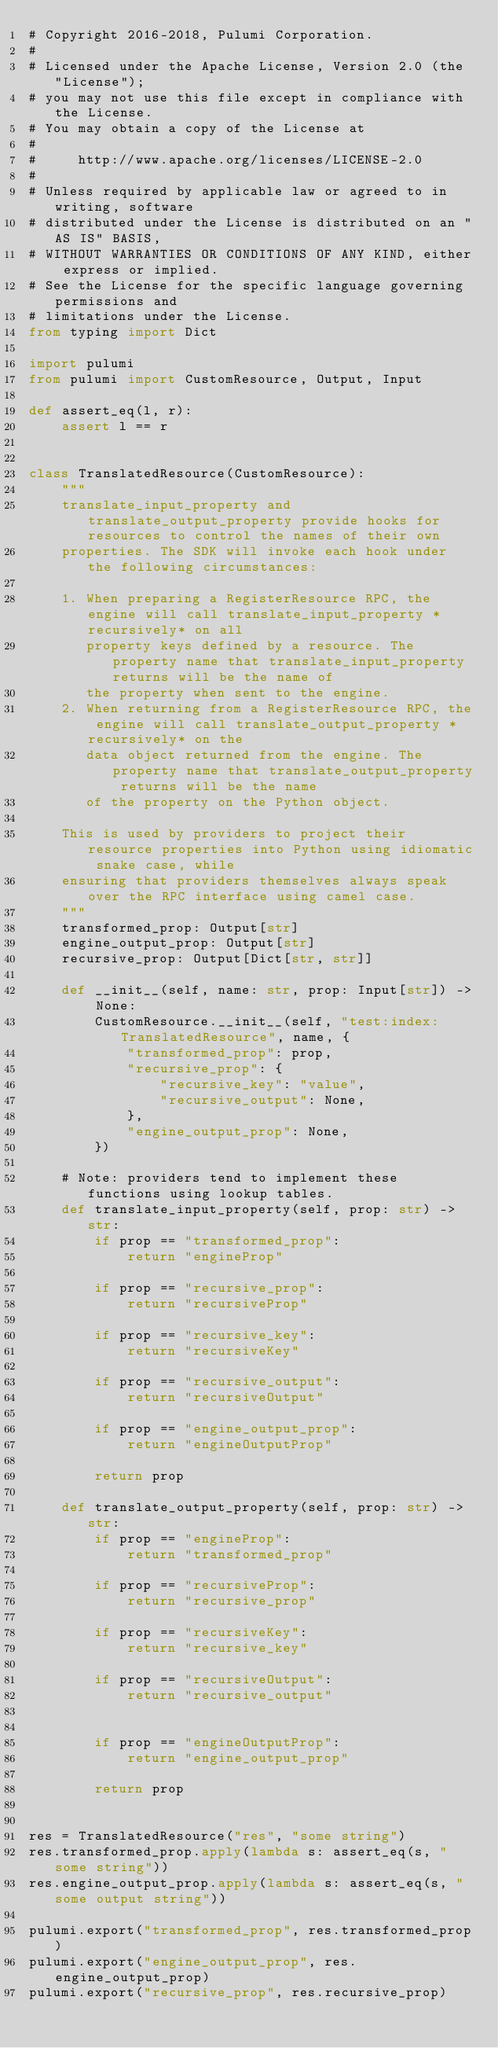Convert code to text. <code><loc_0><loc_0><loc_500><loc_500><_Python_># Copyright 2016-2018, Pulumi Corporation.
#
# Licensed under the Apache License, Version 2.0 (the "License");
# you may not use this file except in compliance with the License.
# You may obtain a copy of the License at
#
#     http://www.apache.org/licenses/LICENSE-2.0
#
# Unless required by applicable law or agreed to in writing, software
# distributed under the License is distributed on an "AS IS" BASIS,
# WITHOUT WARRANTIES OR CONDITIONS OF ANY KIND, either express or implied.
# See the License for the specific language governing permissions and
# limitations under the License.
from typing import Dict

import pulumi
from pulumi import CustomResource, Output, Input

def assert_eq(l, r):
    assert l == r


class TranslatedResource(CustomResource):
    """
    translate_input_property and translate_output_property provide hooks for resources to control the names of their own
    properties. The SDK will invoke each hook under the following circumstances:

    1. When preparing a RegisterResource RPC, the engine will call translate_input_property *recursively* on all
       property keys defined by a resource. The property name that translate_input_property returns will be the name of
       the property when sent to the engine.
    2. When returning from a RegisterResource RPC, the engine will call translate_output_property *recursively* on the
       data object returned from the engine. The property name that translate_output_property returns will be the name
       of the property on the Python object.

    This is used by providers to project their resource properties into Python using idiomatic snake case, while
    ensuring that providers themselves always speak over the RPC interface using camel case.
    """
    transformed_prop: Output[str]
    engine_output_prop: Output[str]
    recursive_prop: Output[Dict[str, str]]

    def __init__(self, name: str, prop: Input[str]) -> None:
        CustomResource.__init__(self, "test:index:TranslatedResource", name, {
            "transformed_prop": prop,
            "recursive_prop": {
                "recursive_key": "value",
                "recursive_output": None,
            },
            "engine_output_prop": None,
        })

    # Note: providers tend to implement these functions using lookup tables.
    def translate_input_property(self, prop: str) -> str:
        if prop == "transformed_prop":
            return "engineProp"

        if prop == "recursive_prop":
            return "recursiveProp"

        if prop == "recursive_key":
            return "recursiveKey"

        if prop == "recursive_output":
            return "recursiveOutput"

        if prop == "engine_output_prop":
            return "engineOutputProp"

        return prop

    def translate_output_property(self, prop: str) -> str:
        if prop == "engineProp":
            return "transformed_prop"

        if prop == "recursiveProp":
            return "recursive_prop"

        if prop == "recursiveKey":
            return "recursive_key"

        if prop == "recursiveOutput":
            return "recursive_output"


        if prop == "engineOutputProp":
            return "engine_output_prop"

        return prop


res = TranslatedResource("res", "some string")
res.transformed_prop.apply(lambda s: assert_eq(s, "some string"))
res.engine_output_prop.apply(lambda s: assert_eq(s, "some output string"))

pulumi.export("transformed_prop", res.transformed_prop)
pulumi.export("engine_output_prop", res.engine_output_prop)
pulumi.export("recursive_prop", res.recursive_prop)
</code> 